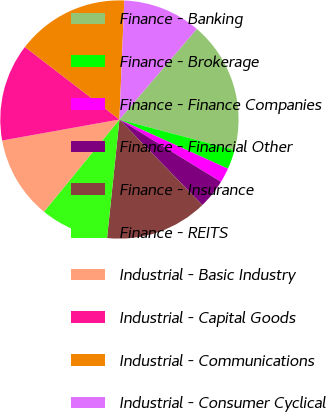Convert chart. <chart><loc_0><loc_0><loc_500><loc_500><pie_chart><fcel>Finance - Banking<fcel>Finance - Brokerage<fcel>Finance - Finance Companies<fcel>Finance - Financial Other<fcel>Finance - Insurance<fcel>Finance - REITS<fcel>Industrial - Basic Industry<fcel>Industrial - Capital Goods<fcel>Industrial - Communications<fcel>Industrial - Consumer Cyclical<nl><fcel>17.88%<fcel>2.65%<fcel>1.99%<fcel>3.98%<fcel>13.91%<fcel>9.27%<fcel>11.26%<fcel>13.24%<fcel>15.23%<fcel>10.6%<nl></chart> 